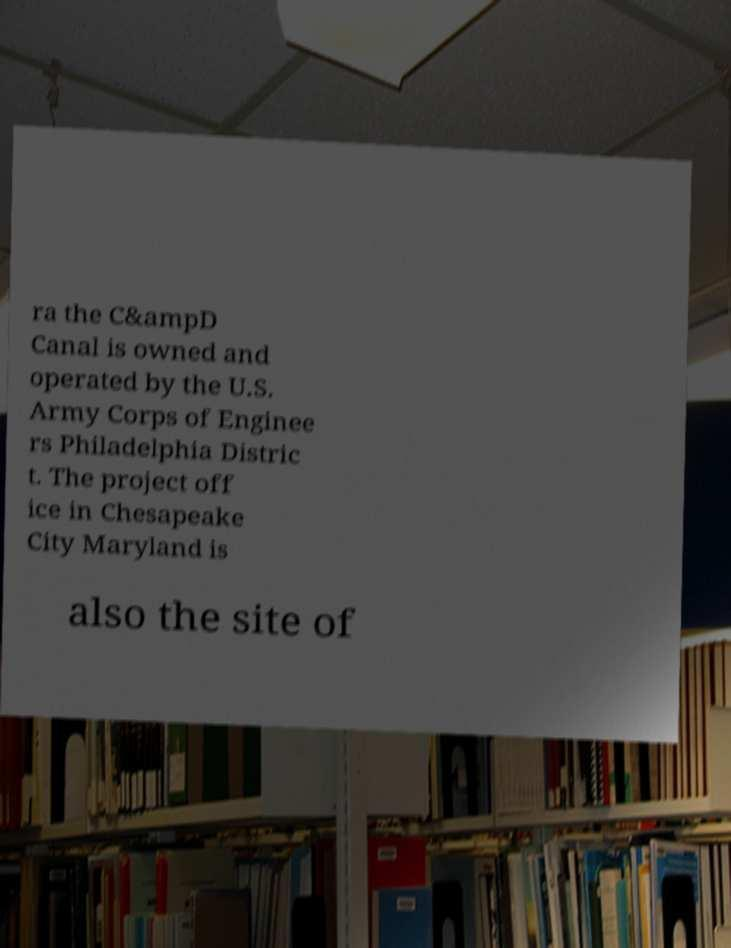For documentation purposes, I need the text within this image transcribed. Could you provide that? ra the C&ampD Canal is owned and operated by the U.S. Army Corps of Enginee rs Philadelphia Distric t. The project off ice in Chesapeake City Maryland is also the site of 